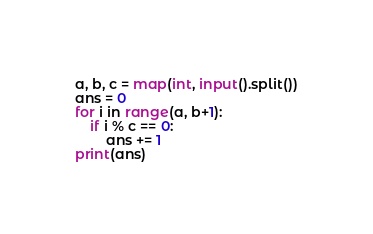Convert code to text. <code><loc_0><loc_0><loc_500><loc_500><_Python_>a, b, c = map(int, input().split())
ans = 0
for i in range(a, b+1):
    if i % c == 0:
        ans += 1
print(ans)
</code> 